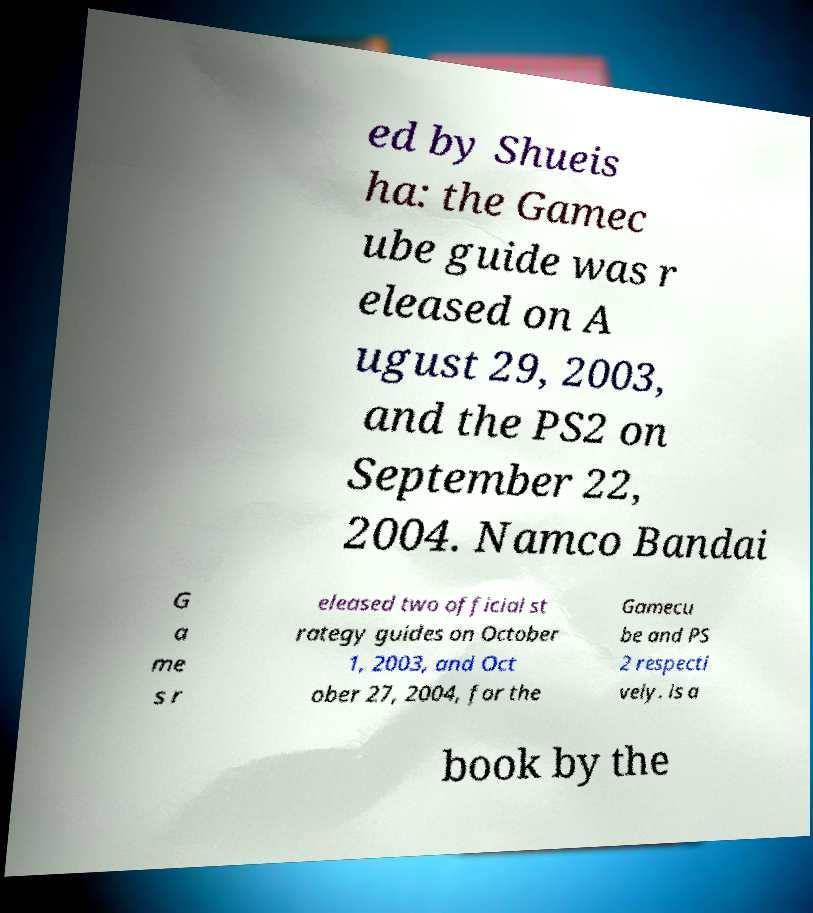For documentation purposes, I need the text within this image transcribed. Could you provide that? ed by Shueis ha: the Gamec ube guide was r eleased on A ugust 29, 2003, and the PS2 on September 22, 2004. Namco Bandai G a me s r eleased two official st rategy guides on October 1, 2003, and Oct ober 27, 2004, for the Gamecu be and PS 2 respecti vely. is a book by the 